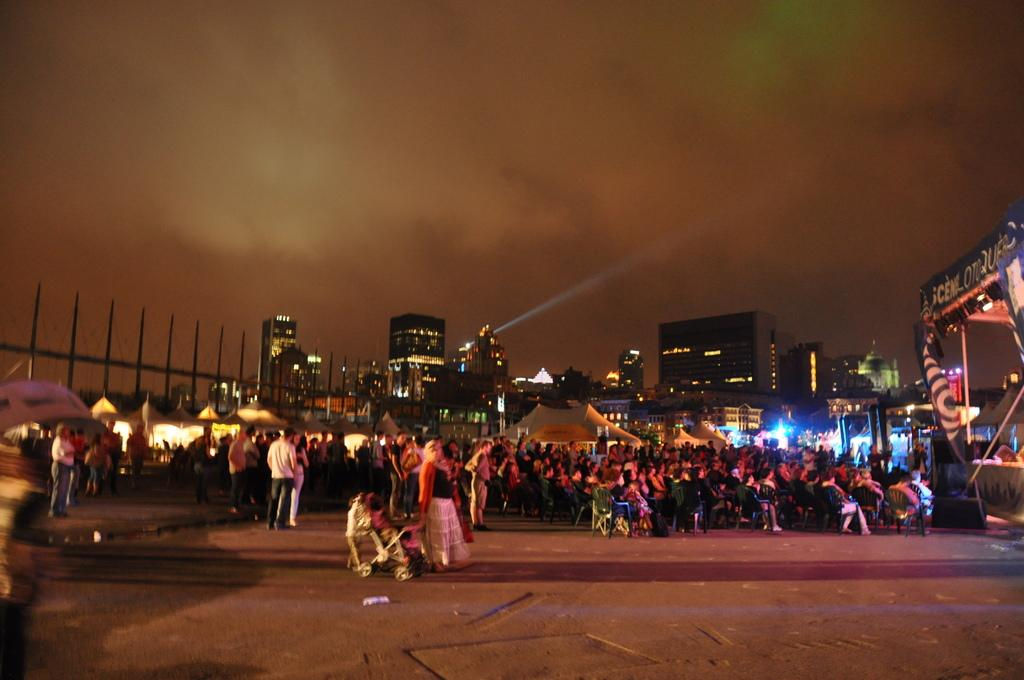What are the people in the image doing? There are people standing and sitting on chairs in the image. What can be seen in the background of the image? There are tents, buildings, lights, banners, and poles visible in the background. How would you describe the sky in the image? The sky is cloudy in the image. Can you see your mom wearing a crown in the image? There is no mention of a mom or a crown in the image; the focus is on the people, background, and sky. 